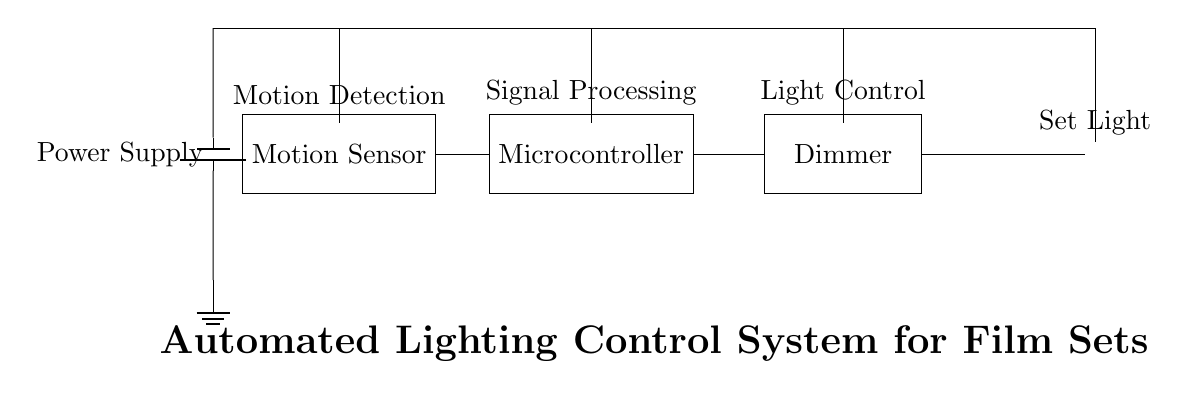What is the main function of the motion sensor? The motion sensor detects movement, which triggers the system to respond by activating the lighting.
Answer: Motion detection Which component processes the signals from the motion sensor? The microcontroller receives input from the motion sensor, processes the information, and controls the dimmer based on the detected movement.
Answer: Microcontroller What type of control does the dimmer provide? The dimmer adjusts the brightness of the light based on signals received from the microcontroller, allowing for flexibility in lighting conditions on the film set.
Answer: Light control How many main components are there in this circuit? The circuit includes four main components: the motion sensor, microcontroller, dimmer, and light.
Answer: Four What supplies power to the circuit? The power supply is a battery that provides the necessary voltage to all components of the circuit.
Answer: Battery What happens if the motion sensor detects no movement? If the motion sensor detects no movement, the microcontroller may keep the light off or dimmed to save energy until motion is detected again.
Answer: Light off or dimmed What is the purpose of the connections in this circuit? The connections facilitate the flow of electric signals and power between the components, ensuring that the system operates correctly in response to motion detection.
Answer: Signal and power flow 